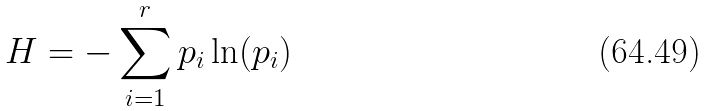<formula> <loc_0><loc_0><loc_500><loc_500>H = - \sum _ { i = 1 } ^ { r } p _ { i } \ln ( p _ { i } )</formula> 